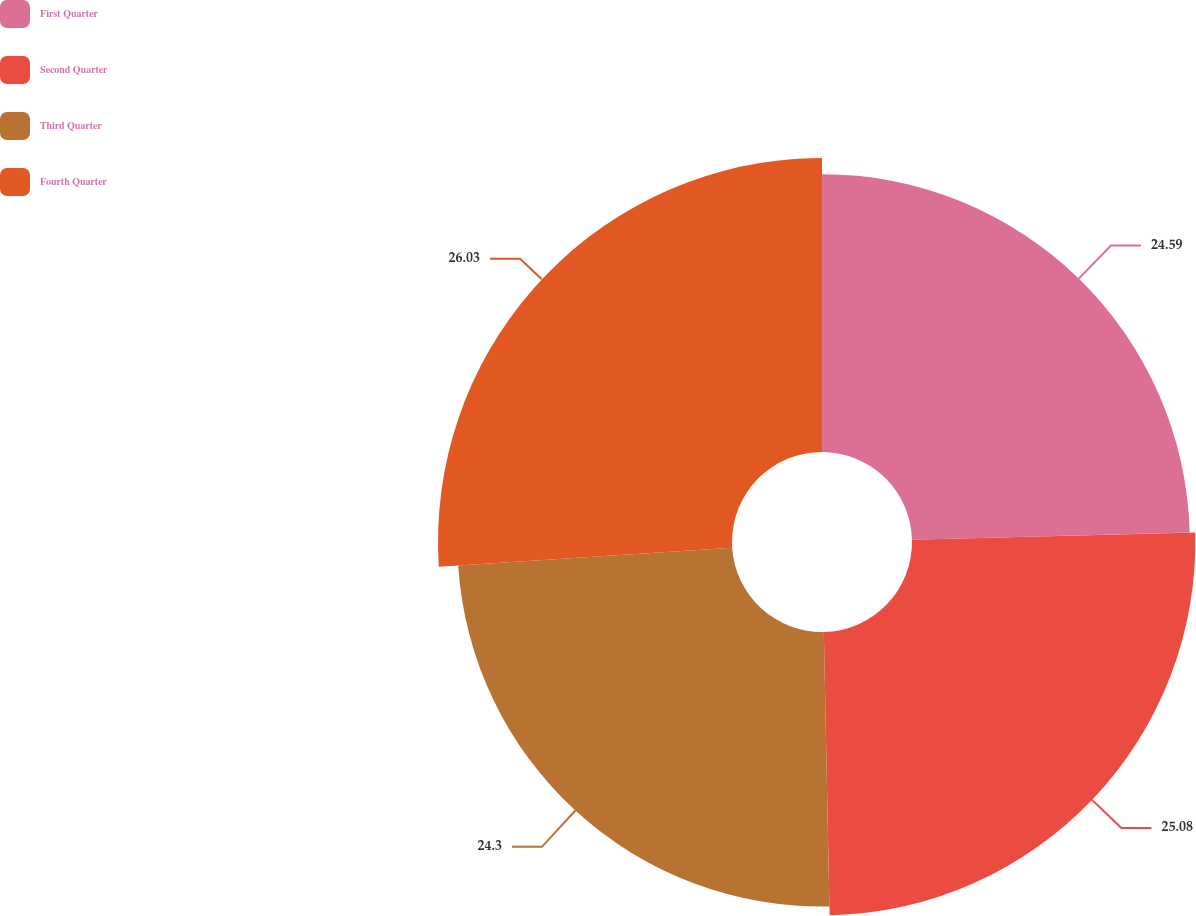<chart> <loc_0><loc_0><loc_500><loc_500><pie_chart><fcel>First Quarter<fcel>Second Quarter<fcel>Third Quarter<fcel>Fourth Quarter<nl><fcel>24.59%<fcel>25.08%<fcel>24.3%<fcel>26.02%<nl></chart> 